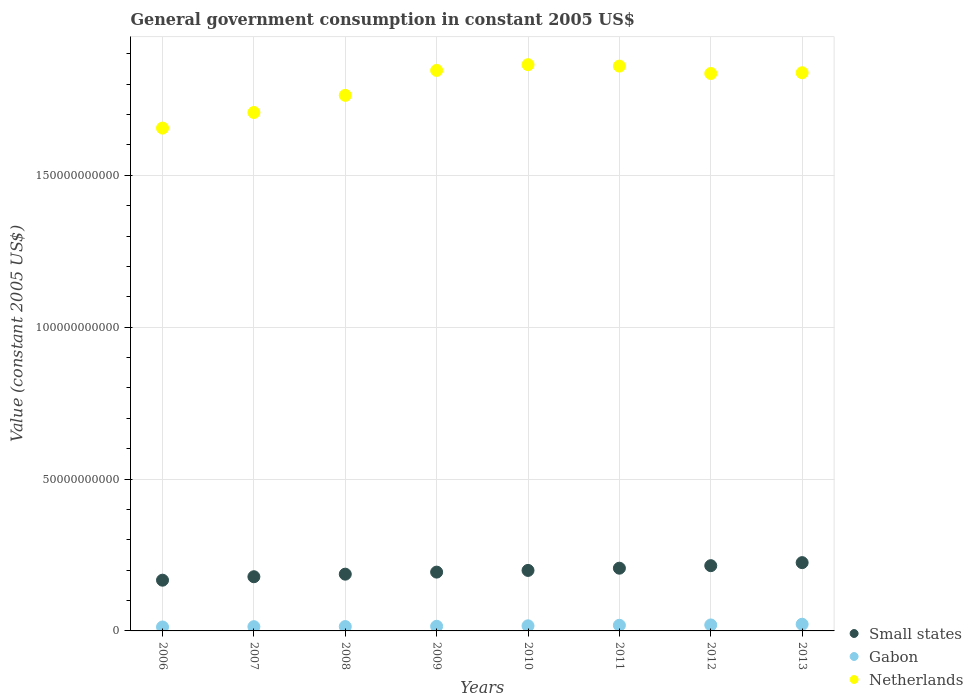How many different coloured dotlines are there?
Keep it short and to the point. 3. What is the government conusmption in Netherlands in 2011?
Offer a terse response. 1.86e+11. Across all years, what is the maximum government conusmption in Gabon?
Your response must be concise. 2.20e+09. Across all years, what is the minimum government conusmption in Small states?
Provide a succinct answer. 1.67e+1. In which year was the government conusmption in Netherlands maximum?
Your answer should be compact. 2010. What is the total government conusmption in Small states in the graph?
Make the answer very short. 1.57e+11. What is the difference between the government conusmption in Gabon in 2010 and that in 2012?
Ensure brevity in your answer.  -2.80e+08. What is the difference between the government conusmption in Small states in 2013 and the government conusmption in Gabon in 2007?
Your answer should be very brief. 2.11e+1. What is the average government conusmption in Gabon per year?
Offer a terse response. 1.67e+09. In the year 2011, what is the difference between the government conusmption in Small states and government conusmption in Gabon?
Your response must be concise. 1.88e+1. In how many years, is the government conusmption in Gabon greater than 70000000000 US$?
Provide a short and direct response. 0. What is the ratio of the government conusmption in Small states in 2007 to that in 2013?
Ensure brevity in your answer.  0.79. Is the government conusmption in Small states in 2011 less than that in 2013?
Offer a very short reply. Yes. Is the difference between the government conusmption in Small states in 2011 and 2012 greater than the difference between the government conusmption in Gabon in 2011 and 2012?
Keep it short and to the point. No. What is the difference between the highest and the second highest government conusmption in Netherlands?
Ensure brevity in your answer.  4.61e+08. What is the difference between the highest and the lowest government conusmption in Small states?
Your answer should be very brief. 5.78e+09. Is the sum of the government conusmption in Netherlands in 2006 and 2010 greater than the maximum government conusmption in Gabon across all years?
Make the answer very short. Yes. Is it the case that in every year, the sum of the government conusmption in Small states and government conusmption in Gabon  is greater than the government conusmption in Netherlands?
Your answer should be very brief. No. Does the government conusmption in Gabon monotonically increase over the years?
Your answer should be very brief. Yes. Are the values on the major ticks of Y-axis written in scientific E-notation?
Your response must be concise. No. Does the graph contain any zero values?
Keep it short and to the point. No. How many legend labels are there?
Ensure brevity in your answer.  3. How are the legend labels stacked?
Keep it short and to the point. Vertical. What is the title of the graph?
Offer a terse response. General government consumption in constant 2005 US$. Does "Iraq" appear as one of the legend labels in the graph?
Give a very brief answer. No. What is the label or title of the Y-axis?
Your answer should be compact. Value (constant 2005 US$). What is the Value (constant 2005 US$) in Small states in 2006?
Your answer should be very brief. 1.67e+1. What is the Value (constant 2005 US$) in Gabon in 2006?
Your answer should be compact. 1.29e+09. What is the Value (constant 2005 US$) of Netherlands in 2006?
Give a very brief answer. 1.66e+11. What is the Value (constant 2005 US$) of Small states in 2007?
Provide a succinct answer. 1.78e+1. What is the Value (constant 2005 US$) in Gabon in 2007?
Ensure brevity in your answer.  1.40e+09. What is the Value (constant 2005 US$) of Netherlands in 2007?
Your answer should be compact. 1.71e+11. What is the Value (constant 2005 US$) of Small states in 2008?
Provide a succinct answer. 1.87e+1. What is the Value (constant 2005 US$) of Gabon in 2008?
Make the answer very short. 1.43e+09. What is the Value (constant 2005 US$) of Netherlands in 2008?
Your response must be concise. 1.76e+11. What is the Value (constant 2005 US$) in Small states in 2009?
Offer a very short reply. 1.94e+1. What is the Value (constant 2005 US$) in Gabon in 2009?
Make the answer very short. 1.53e+09. What is the Value (constant 2005 US$) in Netherlands in 2009?
Your answer should be compact. 1.85e+11. What is the Value (constant 2005 US$) in Small states in 2010?
Offer a very short reply. 1.99e+1. What is the Value (constant 2005 US$) of Gabon in 2010?
Ensure brevity in your answer.  1.69e+09. What is the Value (constant 2005 US$) of Netherlands in 2010?
Your answer should be very brief. 1.86e+11. What is the Value (constant 2005 US$) of Small states in 2011?
Ensure brevity in your answer.  2.06e+1. What is the Value (constant 2005 US$) of Gabon in 2011?
Offer a very short reply. 1.86e+09. What is the Value (constant 2005 US$) in Netherlands in 2011?
Your response must be concise. 1.86e+11. What is the Value (constant 2005 US$) in Small states in 2012?
Your response must be concise. 2.15e+1. What is the Value (constant 2005 US$) of Gabon in 2012?
Offer a very short reply. 1.97e+09. What is the Value (constant 2005 US$) in Netherlands in 2012?
Offer a terse response. 1.83e+11. What is the Value (constant 2005 US$) of Small states in 2013?
Your answer should be compact. 2.25e+1. What is the Value (constant 2005 US$) of Gabon in 2013?
Provide a succinct answer. 2.20e+09. What is the Value (constant 2005 US$) of Netherlands in 2013?
Offer a terse response. 1.84e+11. Across all years, what is the maximum Value (constant 2005 US$) of Small states?
Your response must be concise. 2.25e+1. Across all years, what is the maximum Value (constant 2005 US$) in Gabon?
Offer a very short reply. 2.20e+09. Across all years, what is the maximum Value (constant 2005 US$) in Netherlands?
Your response must be concise. 1.86e+11. Across all years, what is the minimum Value (constant 2005 US$) in Small states?
Make the answer very short. 1.67e+1. Across all years, what is the minimum Value (constant 2005 US$) in Gabon?
Provide a short and direct response. 1.29e+09. Across all years, what is the minimum Value (constant 2005 US$) of Netherlands?
Offer a terse response. 1.66e+11. What is the total Value (constant 2005 US$) of Small states in the graph?
Keep it short and to the point. 1.57e+11. What is the total Value (constant 2005 US$) in Gabon in the graph?
Make the answer very short. 1.34e+1. What is the total Value (constant 2005 US$) of Netherlands in the graph?
Give a very brief answer. 1.44e+12. What is the difference between the Value (constant 2005 US$) in Small states in 2006 and that in 2007?
Keep it short and to the point. -1.14e+09. What is the difference between the Value (constant 2005 US$) in Gabon in 2006 and that in 2007?
Offer a very short reply. -1.03e+08. What is the difference between the Value (constant 2005 US$) of Netherlands in 2006 and that in 2007?
Offer a very short reply. -5.14e+09. What is the difference between the Value (constant 2005 US$) of Small states in 2006 and that in 2008?
Your answer should be very brief. -1.98e+09. What is the difference between the Value (constant 2005 US$) of Gabon in 2006 and that in 2008?
Give a very brief answer. -1.40e+08. What is the difference between the Value (constant 2005 US$) of Netherlands in 2006 and that in 2008?
Your answer should be compact. -1.08e+1. What is the difference between the Value (constant 2005 US$) of Small states in 2006 and that in 2009?
Make the answer very short. -2.66e+09. What is the difference between the Value (constant 2005 US$) of Gabon in 2006 and that in 2009?
Make the answer very short. -2.36e+08. What is the difference between the Value (constant 2005 US$) in Netherlands in 2006 and that in 2009?
Offer a very short reply. -1.90e+1. What is the difference between the Value (constant 2005 US$) in Small states in 2006 and that in 2010?
Offer a terse response. -3.22e+09. What is the difference between the Value (constant 2005 US$) in Gabon in 2006 and that in 2010?
Provide a succinct answer. -3.93e+08. What is the difference between the Value (constant 2005 US$) of Netherlands in 2006 and that in 2010?
Provide a succinct answer. -2.09e+1. What is the difference between the Value (constant 2005 US$) of Small states in 2006 and that in 2011?
Provide a short and direct response. -3.95e+09. What is the difference between the Value (constant 2005 US$) of Gabon in 2006 and that in 2011?
Provide a short and direct response. -5.65e+08. What is the difference between the Value (constant 2005 US$) of Netherlands in 2006 and that in 2011?
Keep it short and to the point. -2.04e+1. What is the difference between the Value (constant 2005 US$) in Small states in 2006 and that in 2012?
Ensure brevity in your answer.  -4.77e+09. What is the difference between the Value (constant 2005 US$) in Gabon in 2006 and that in 2012?
Your answer should be compact. -6.73e+08. What is the difference between the Value (constant 2005 US$) in Netherlands in 2006 and that in 2012?
Make the answer very short. -1.80e+1. What is the difference between the Value (constant 2005 US$) of Small states in 2006 and that in 2013?
Offer a terse response. -5.78e+09. What is the difference between the Value (constant 2005 US$) of Gabon in 2006 and that in 2013?
Offer a very short reply. -9.06e+08. What is the difference between the Value (constant 2005 US$) in Netherlands in 2006 and that in 2013?
Your response must be concise. -1.82e+1. What is the difference between the Value (constant 2005 US$) of Small states in 2007 and that in 2008?
Keep it short and to the point. -8.44e+08. What is the difference between the Value (constant 2005 US$) in Gabon in 2007 and that in 2008?
Make the answer very short. -3.73e+07. What is the difference between the Value (constant 2005 US$) of Netherlands in 2007 and that in 2008?
Offer a terse response. -5.64e+09. What is the difference between the Value (constant 2005 US$) in Small states in 2007 and that in 2009?
Your answer should be compact. -1.52e+09. What is the difference between the Value (constant 2005 US$) of Gabon in 2007 and that in 2009?
Ensure brevity in your answer.  -1.33e+08. What is the difference between the Value (constant 2005 US$) in Netherlands in 2007 and that in 2009?
Your answer should be compact. -1.39e+1. What is the difference between the Value (constant 2005 US$) in Small states in 2007 and that in 2010?
Your answer should be compact. -2.08e+09. What is the difference between the Value (constant 2005 US$) in Gabon in 2007 and that in 2010?
Offer a very short reply. -2.90e+08. What is the difference between the Value (constant 2005 US$) in Netherlands in 2007 and that in 2010?
Your response must be concise. -1.57e+1. What is the difference between the Value (constant 2005 US$) of Small states in 2007 and that in 2011?
Your response must be concise. -2.81e+09. What is the difference between the Value (constant 2005 US$) of Gabon in 2007 and that in 2011?
Your answer should be compact. -4.62e+08. What is the difference between the Value (constant 2005 US$) in Netherlands in 2007 and that in 2011?
Make the answer very short. -1.53e+1. What is the difference between the Value (constant 2005 US$) of Small states in 2007 and that in 2012?
Your answer should be compact. -3.64e+09. What is the difference between the Value (constant 2005 US$) of Gabon in 2007 and that in 2012?
Offer a terse response. -5.70e+08. What is the difference between the Value (constant 2005 US$) in Netherlands in 2007 and that in 2012?
Give a very brief answer. -1.28e+1. What is the difference between the Value (constant 2005 US$) of Small states in 2007 and that in 2013?
Your answer should be very brief. -4.64e+09. What is the difference between the Value (constant 2005 US$) in Gabon in 2007 and that in 2013?
Provide a short and direct response. -8.03e+08. What is the difference between the Value (constant 2005 US$) of Netherlands in 2007 and that in 2013?
Make the answer very short. -1.31e+1. What is the difference between the Value (constant 2005 US$) of Small states in 2008 and that in 2009?
Make the answer very short. -6.75e+08. What is the difference between the Value (constant 2005 US$) of Gabon in 2008 and that in 2009?
Make the answer very short. -9.54e+07. What is the difference between the Value (constant 2005 US$) in Netherlands in 2008 and that in 2009?
Give a very brief answer. -8.21e+09. What is the difference between the Value (constant 2005 US$) of Small states in 2008 and that in 2010?
Offer a terse response. -1.23e+09. What is the difference between the Value (constant 2005 US$) of Gabon in 2008 and that in 2010?
Keep it short and to the point. -2.53e+08. What is the difference between the Value (constant 2005 US$) in Netherlands in 2008 and that in 2010?
Give a very brief answer. -1.01e+1. What is the difference between the Value (constant 2005 US$) in Small states in 2008 and that in 2011?
Make the answer very short. -1.97e+09. What is the difference between the Value (constant 2005 US$) in Gabon in 2008 and that in 2011?
Ensure brevity in your answer.  -4.25e+08. What is the difference between the Value (constant 2005 US$) in Netherlands in 2008 and that in 2011?
Your answer should be very brief. -9.63e+09. What is the difference between the Value (constant 2005 US$) of Small states in 2008 and that in 2012?
Provide a short and direct response. -2.79e+09. What is the difference between the Value (constant 2005 US$) of Gabon in 2008 and that in 2012?
Provide a succinct answer. -5.33e+08. What is the difference between the Value (constant 2005 US$) in Netherlands in 2008 and that in 2012?
Offer a very short reply. -7.19e+09. What is the difference between the Value (constant 2005 US$) in Small states in 2008 and that in 2013?
Keep it short and to the point. -3.79e+09. What is the difference between the Value (constant 2005 US$) in Gabon in 2008 and that in 2013?
Ensure brevity in your answer.  -7.66e+08. What is the difference between the Value (constant 2005 US$) of Netherlands in 2008 and that in 2013?
Make the answer very short. -7.44e+09. What is the difference between the Value (constant 2005 US$) of Small states in 2009 and that in 2010?
Keep it short and to the point. -5.59e+08. What is the difference between the Value (constant 2005 US$) of Gabon in 2009 and that in 2010?
Make the answer very short. -1.57e+08. What is the difference between the Value (constant 2005 US$) in Netherlands in 2009 and that in 2010?
Give a very brief answer. -1.89e+09. What is the difference between the Value (constant 2005 US$) in Small states in 2009 and that in 2011?
Your answer should be very brief. -1.29e+09. What is the difference between the Value (constant 2005 US$) of Gabon in 2009 and that in 2011?
Your answer should be compact. -3.30e+08. What is the difference between the Value (constant 2005 US$) of Netherlands in 2009 and that in 2011?
Ensure brevity in your answer.  -1.42e+09. What is the difference between the Value (constant 2005 US$) in Small states in 2009 and that in 2012?
Your response must be concise. -2.12e+09. What is the difference between the Value (constant 2005 US$) in Gabon in 2009 and that in 2012?
Offer a very short reply. -4.38e+08. What is the difference between the Value (constant 2005 US$) in Netherlands in 2009 and that in 2012?
Your response must be concise. 1.02e+09. What is the difference between the Value (constant 2005 US$) in Small states in 2009 and that in 2013?
Your answer should be compact. -3.12e+09. What is the difference between the Value (constant 2005 US$) of Gabon in 2009 and that in 2013?
Your response must be concise. -6.71e+08. What is the difference between the Value (constant 2005 US$) in Netherlands in 2009 and that in 2013?
Provide a short and direct response. 7.69e+08. What is the difference between the Value (constant 2005 US$) of Small states in 2010 and that in 2011?
Your response must be concise. -7.31e+08. What is the difference between the Value (constant 2005 US$) of Gabon in 2010 and that in 2011?
Make the answer very short. -1.72e+08. What is the difference between the Value (constant 2005 US$) in Netherlands in 2010 and that in 2011?
Provide a succinct answer. 4.61e+08. What is the difference between the Value (constant 2005 US$) of Small states in 2010 and that in 2012?
Give a very brief answer. -1.56e+09. What is the difference between the Value (constant 2005 US$) of Gabon in 2010 and that in 2012?
Make the answer very short. -2.80e+08. What is the difference between the Value (constant 2005 US$) of Netherlands in 2010 and that in 2012?
Make the answer very short. 2.90e+09. What is the difference between the Value (constant 2005 US$) of Small states in 2010 and that in 2013?
Provide a short and direct response. -2.56e+09. What is the difference between the Value (constant 2005 US$) of Gabon in 2010 and that in 2013?
Your response must be concise. -5.13e+08. What is the difference between the Value (constant 2005 US$) in Netherlands in 2010 and that in 2013?
Provide a succinct answer. 2.65e+09. What is the difference between the Value (constant 2005 US$) of Small states in 2011 and that in 2012?
Offer a very short reply. -8.27e+08. What is the difference between the Value (constant 2005 US$) of Gabon in 2011 and that in 2012?
Offer a very short reply. -1.08e+08. What is the difference between the Value (constant 2005 US$) in Netherlands in 2011 and that in 2012?
Offer a very short reply. 2.44e+09. What is the difference between the Value (constant 2005 US$) in Small states in 2011 and that in 2013?
Your answer should be compact. -1.83e+09. What is the difference between the Value (constant 2005 US$) in Gabon in 2011 and that in 2013?
Offer a very short reply. -3.41e+08. What is the difference between the Value (constant 2005 US$) of Netherlands in 2011 and that in 2013?
Offer a terse response. 2.19e+09. What is the difference between the Value (constant 2005 US$) in Small states in 2012 and that in 2013?
Your answer should be compact. -1.00e+09. What is the difference between the Value (constant 2005 US$) of Gabon in 2012 and that in 2013?
Your answer should be very brief. -2.33e+08. What is the difference between the Value (constant 2005 US$) in Netherlands in 2012 and that in 2013?
Your answer should be very brief. -2.47e+08. What is the difference between the Value (constant 2005 US$) in Small states in 2006 and the Value (constant 2005 US$) in Gabon in 2007?
Ensure brevity in your answer.  1.53e+1. What is the difference between the Value (constant 2005 US$) in Small states in 2006 and the Value (constant 2005 US$) in Netherlands in 2007?
Provide a succinct answer. -1.54e+11. What is the difference between the Value (constant 2005 US$) of Gabon in 2006 and the Value (constant 2005 US$) of Netherlands in 2007?
Give a very brief answer. -1.69e+11. What is the difference between the Value (constant 2005 US$) in Small states in 2006 and the Value (constant 2005 US$) in Gabon in 2008?
Offer a terse response. 1.53e+1. What is the difference between the Value (constant 2005 US$) in Small states in 2006 and the Value (constant 2005 US$) in Netherlands in 2008?
Provide a short and direct response. -1.60e+11. What is the difference between the Value (constant 2005 US$) of Gabon in 2006 and the Value (constant 2005 US$) of Netherlands in 2008?
Ensure brevity in your answer.  -1.75e+11. What is the difference between the Value (constant 2005 US$) of Small states in 2006 and the Value (constant 2005 US$) of Gabon in 2009?
Make the answer very short. 1.52e+1. What is the difference between the Value (constant 2005 US$) of Small states in 2006 and the Value (constant 2005 US$) of Netherlands in 2009?
Your answer should be very brief. -1.68e+11. What is the difference between the Value (constant 2005 US$) of Gabon in 2006 and the Value (constant 2005 US$) of Netherlands in 2009?
Offer a terse response. -1.83e+11. What is the difference between the Value (constant 2005 US$) in Small states in 2006 and the Value (constant 2005 US$) in Gabon in 2010?
Ensure brevity in your answer.  1.50e+1. What is the difference between the Value (constant 2005 US$) of Small states in 2006 and the Value (constant 2005 US$) of Netherlands in 2010?
Offer a very short reply. -1.70e+11. What is the difference between the Value (constant 2005 US$) in Gabon in 2006 and the Value (constant 2005 US$) in Netherlands in 2010?
Keep it short and to the point. -1.85e+11. What is the difference between the Value (constant 2005 US$) of Small states in 2006 and the Value (constant 2005 US$) of Gabon in 2011?
Give a very brief answer. 1.48e+1. What is the difference between the Value (constant 2005 US$) of Small states in 2006 and the Value (constant 2005 US$) of Netherlands in 2011?
Your answer should be compact. -1.69e+11. What is the difference between the Value (constant 2005 US$) of Gabon in 2006 and the Value (constant 2005 US$) of Netherlands in 2011?
Keep it short and to the point. -1.85e+11. What is the difference between the Value (constant 2005 US$) of Small states in 2006 and the Value (constant 2005 US$) of Gabon in 2012?
Your answer should be compact. 1.47e+1. What is the difference between the Value (constant 2005 US$) of Small states in 2006 and the Value (constant 2005 US$) of Netherlands in 2012?
Provide a short and direct response. -1.67e+11. What is the difference between the Value (constant 2005 US$) of Gabon in 2006 and the Value (constant 2005 US$) of Netherlands in 2012?
Give a very brief answer. -1.82e+11. What is the difference between the Value (constant 2005 US$) of Small states in 2006 and the Value (constant 2005 US$) of Gabon in 2013?
Your answer should be very brief. 1.45e+1. What is the difference between the Value (constant 2005 US$) of Small states in 2006 and the Value (constant 2005 US$) of Netherlands in 2013?
Provide a succinct answer. -1.67e+11. What is the difference between the Value (constant 2005 US$) in Gabon in 2006 and the Value (constant 2005 US$) in Netherlands in 2013?
Your answer should be compact. -1.82e+11. What is the difference between the Value (constant 2005 US$) of Small states in 2007 and the Value (constant 2005 US$) of Gabon in 2008?
Your answer should be compact. 1.64e+1. What is the difference between the Value (constant 2005 US$) in Small states in 2007 and the Value (constant 2005 US$) in Netherlands in 2008?
Offer a very short reply. -1.58e+11. What is the difference between the Value (constant 2005 US$) in Gabon in 2007 and the Value (constant 2005 US$) in Netherlands in 2008?
Provide a short and direct response. -1.75e+11. What is the difference between the Value (constant 2005 US$) of Small states in 2007 and the Value (constant 2005 US$) of Gabon in 2009?
Give a very brief answer. 1.63e+1. What is the difference between the Value (constant 2005 US$) of Small states in 2007 and the Value (constant 2005 US$) of Netherlands in 2009?
Keep it short and to the point. -1.67e+11. What is the difference between the Value (constant 2005 US$) of Gabon in 2007 and the Value (constant 2005 US$) of Netherlands in 2009?
Provide a succinct answer. -1.83e+11. What is the difference between the Value (constant 2005 US$) of Small states in 2007 and the Value (constant 2005 US$) of Gabon in 2010?
Keep it short and to the point. 1.62e+1. What is the difference between the Value (constant 2005 US$) of Small states in 2007 and the Value (constant 2005 US$) of Netherlands in 2010?
Provide a short and direct response. -1.69e+11. What is the difference between the Value (constant 2005 US$) in Gabon in 2007 and the Value (constant 2005 US$) in Netherlands in 2010?
Offer a very short reply. -1.85e+11. What is the difference between the Value (constant 2005 US$) of Small states in 2007 and the Value (constant 2005 US$) of Gabon in 2011?
Give a very brief answer. 1.60e+1. What is the difference between the Value (constant 2005 US$) in Small states in 2007 and the Value (constant 2005 US$) in Netherlands in 2011?
Offer a terse response. -1.68e+11. What is the difference between the Value (constant 2005 US$) of Gabon in 2007 and the Value (constant 2005 US$) of Netherlands in 2011?
Give a very brief answer. -1.85e+11. What is the difference between the Value (constant 2005 US$) in Small states in 2007 and the Value (constant 2005 US$) in Gabon in 2012?
Your answer should be very brief. 1.59e+1. What is the difference between the Value (constant 2005 US$) of Small states in 2007 and the Value (constant 2005 US$) of Netherlands in 2012?
Your answer should be very brief. -1.66e+11. What is the difference between the Value (constant 2005 US$) of Gabon in 2007 and the Value (constant 2005 US$) of Netherlands in 2012?
Make the answer very short. -1.82e+11. What is the difference between the Value (constant 2005 US$) in Small states in 2007 and the Value (constant 2005 US$) in Gabon in 2013?
Provide a succinct answer. 1.56e+1. What is the difference between the Value (constant 2005 US$) of Small states in 2007 and the Value (constant 2005 US$) of Netherlands in 2013?
Your answer should be compact. -1.66e+11. What is the difference between the Value (constant 2005 US$) in Gabon in 2007 and the Value (constant 2005 US$) in Netherlands in 2013?
Your answer should be compact. -1.82e+11. What is the difference between the Value (constant 2005 US$) of Small states in 2008 and the Value (constant 2005 US$) of Gabon in 2009?
Provide a succinct answer. 1.72e+1. What is the difference between the Value (constant 2005 US$) in Small states in 2008 and the Value (constant 2005 US$) in Netherlands in 2009?
Your response must be concise. -1.66e+11. What is the difference between the Value (constant 2005 US$) in Gabon in 2008 and the Value (constant 2005 US$) in Netherlands in 2009?
Your answer should be very brief. -1.83e+11. What is the difference between the Value (constant 2005 US$) in Small states in 2008 and the Value (constant 2005 US$) in Gabon in 2010?
Offer a terse response. 1.70e+1. What is the difference between the Value (constant 2005 US$) of Small states in 2008 and the Value (constant 2005 US$) of Netherlands in 2010?
Offer a terse response. -1.68e+11. What is the difference between the Value (constant 2005 US$) in Gabon in 2008 and the Value (constant 2005 US$) in Netherlands in 2010?
Offer a terse response. -1.85e+11. What is the difference between the Value (constant 2005 US$) in Small states in 2008 and the Value (constant 2005 US$) in Gabon in 2011?
Offer a very short reply. 1.68e+1. What is the difference between the Value (constant 2005 US$) in Small states in 2008 and the Value (constant 2005 US$) in Netherlands in 2011?
Your response must be concise. -1.67e+11. What is the difference between the Value (constant 2005 US$) of Gabon in 2008 and the Value (constant 2005 US$) of Netherlands in 2011?
Provide a short and direct response. -1.84e+11. What is the difference between the Value (constant 2005 US$) in Small states in 2008 and the Value (constant 2005 US$) in Gabon in 2012?
Make the answer very short. 1.67e+1. What is the difference between the Value (constant 2005 US$) of Small states in 2008 and the Value (constant 2005 US$) of Netherlands in 2012?
Provide a succinct answer. -1.65e+11. What is the difference between the Value (constant 2005 US$) in Gabon in 2008 and the Value (constant 2005 US$) in Netherlands in 2012?
Give a very brief answer. -1.82e+11. What is the difference between the Value (constant 2005 US$) in Small states in 2008 and the Value (constant 2005 US$) in Gabon in 2013?
Offer a terse response. 1.65e+1. What is the difference between the Value (constant 2005 US$) of Small states in 2008 and the Value (constant 2005 US$) of Netherlands in 2013?
Provide a short and direct response. -1.65e+11. What is the difference between the Value (constant 2005 US$) of Gabon in 2008 and the Value (constant 2005 US$) of Netherlands in 2013?
Your answer should be compact. -1.82e+11. What is the difference between the Value (constant 2005 US$) of Small states in 2009 and the Value (constant 2005 US$) of Gabon in 2010?
Give a very brief answer. 1.77e+1. What is the difference between the Value (constant 2005 US$) of Small states in 2009 and the Value (constant 2005 US$) of Netherlands in 2010?
Provide a short and direct response. -1.67e+11. What is the difference between the Value (constant 2005 US$) of Gabon in 2009 and the Value (constant 2005 US$) of Netherlands in 2010?
Your answer should be very brief. -1.85e+11. What is the difference between the Value (constant 2005 US$) of Small states in 2009 and the Value (constant 2005 US$) of Gabon in 2011?
Offer a very short reply. 1.75e+1. What is the difference between the Value (constant 2005 US$) in Small states in 2009 and the Value (constant 2005 US$) in Netherlands in 2011?
Keep it short and to the point. -1.67e+11. What is the difference between the Value (constant 2005 US$) of Gabon in 2009 and the Value (constant 2005 US$) of Netherlands in 2011?
Your response must be concise. -1.84e+11. What is the difference between the Value (constant 2005 US$) in Small states in 2009 and the Value (constant 2005 US$) in Gabon in 2012?
Make the answer very short. 1.74e+1. What is the difference between the Value (constant 2005 US$) of Small states in 2009 and the Value (constant 2005 US$) of Netherlands in 2012?
Provide a short and direct response. -1.64e+11. What is the difference between the Value (constant 2005 US$) in Gabon in 2009 and the Value (constant 2005 US$) in Netherlands in 2012?
Your response must be concise. -1.82e+11. What is the difference between the Value (constant 2005 US$) of Small states in 2009 and the Value (constant 2005 US$) of Gabon in 2013?
Your response must be concise. 1.72e+1. What is the difference between the Value (constant 2005 US$) in Small states in 2009 and the Value (constant 2005 US$) in Netherlands in 2013?
Your answer should be compact. -1.64e+11. What is the difference between the Value (constant 2005 US$) in Gabon in 2009 and the Value (constant 2005 US$) in Netherlands in 2013?
Give a very brief answer. -1.82e+11. What is the difference between the Value (constant 2005 US$) of Small states in 2010 and the Value (constant 2005 US$) of Gabon in 2011?
Your answer should be very brief. 1.81e+1. What is the difference between the Value (constant 2005 US$) in Small states in 2010 and the Value (constant 2005 US$) in Netherlands in 2011?
Give a very brief answer. -1.66e+11. What is the difference between the Value (constant 2005 US$) in Gabon in 2010 and the Value (constant 2005 US$) in Netherlands in 2011?
Provide a succinct answer. -1.84e+11. What is the difference between the Value (constant 2005 US$) of Small states in 2010 and the Value (constant 2005 US$) of Gabon in 2012?
Your answer should be compact. 1.80e+1. What is the difference between the Value (constant 2005 US$) in Small states in 2010 and the Value (constant 2005 US$) in Netherlands in 2012?
Your response must be concise. -1.64e+11. What is the difference between the Value (constant 2005 US$) in Gabon in 2010 and the Value (constant 2005 US$) in Netherlands in 2012?
Provide a short and direct response. -1.82e+11. What is the difference between the Value (constant 2005 US$) in Small states in 2010 and the Value (constant 2005 US$) in Gabon in 2013?
Your response must be concise. 1.77e+1. What is the difference between the Value (constant 2005 US$) of Small states in 2010 and the Value (constant 2005 US$) of Netherlands in 2013?
Ensure brevity in your answer.  -1.64e+11. What is the difference between the Value (constant 2005 US$) of Gabon in 2010 and the Value (constant 2005 US$) of Netherlands in 2013?
Provide a short and direct response. -1.82e+11. What is the difference between the Value (constant 2005 US$) of Small states in 2011 and the Value (constant 2005 US$) of Gabon in 2012?
Give a very brief answer. 1.87e+1. What is the difference between the Value (constant 2005 US$) in Small states in 2011 and the Value (constant 2005 US$) in Netherlands in 2012?
Your response must be concise. -1.63e+11. What is the difference between the Value (constant 2005 US$) of Gabon in 2011 and the Value (constant 2005 US$) of Netherlands in 2012?
Give a very brief answer. -1.82e+11. What is the difference between the Value (constant 2005 US$) of Small states in 2011 and the Value (constant 2005 US$) of Gabon in 2013?
Offer a terse response. 1.85e+1. What is the difference between the Value (constant 2005 US$) in Small states in 2011 and the Value (constant 2005 US$) in Netherlands in 2013?
Offer a very short reply. -1.63e+11. What is the difference between the Value (constant 2005 US$) of Gabon in 2011 and the Value (constant 2005 US$) of Netherlands in 2013?
Offer a very short reply. -1.82e+11. What is the difference between the Value (constant 2005 US$) of Small states in 2012 and the Value (constant 2005 US$) of Gabon in 2013?
Offer a very short reply. 1.93e+1. What is the difference between the Value (constant 2005 US$) in Small states in 2012 and the Value (constant 2005 US$) in Netherlands in 2013?
Your answer should be compact. -1.62e+11. What is the difference between the Value (constant 2005 US$) in Gabon in 2012 and the Value (constant 2005 US$) in Netherlands in 2013?
Offer a very short reply. -1.82e+11. What is the average Value (constant 2005 US$) in Small states per year?
Provide a short and direct response. 1.96e+1. What is the average Value (constant 2005 US$) of Gabon per year?
Ensure brevity in your answer.  1.67e+09. What is the average Value (constant 2005 US$) in Netherlands per year?
Ensure brevity in your answer.  1.80e+11. In the year 2006, what is the difference between the Value (constant 2005 US$) in Small states and Value (constant 2005 US$) in Gabon?
Offer a terse response. 1.54e+1. In the year 2006, what is the difference between the Value (constant 2005 US$) of Small states and Value (constant 2005 US$) of Netherlands?
Ensure brevity in your answer.  -1.49e+11. In the year 2006, what is the difference between the Value (constant 2005 US$) in Gabon and Value (constant 2005 US$) in Netherlands?
Ensure brevity in your answer.  -1.64e+11. In the year 2007, what is the difference between the Value (constant 2005 US$) of Small states and Value (constant 2005 US$) of Gabon?
Offer a very short reply. 1.64e+1. In the year 2007, what is the difference between the Value (constant 2005 US$) of Small states and Value (constant 2005 US$) of Netherlands?
Keep it short and to the point. -1.53e+11. In the year 2007, what is the difference between the Value (constant 2005 US$) of Gabon and Value (constant 2005 US$) of Netherlands?
Offer a very short reply. -1.69e+11. In the year 2008, what is the difference between the Value (constant 2005 US$) of Small states and Value (constant 2005 US$) of Gabon?
Provide a succinct answer. 1.73e+1. In the year 2008, what is the difference between the Value (constant 2005 US$) of Small states and Value (constant 2005 US$) of Netherlands?
Give a very brief answer. -1.58e+11. In the year 2008, what is the difference between the Value (constant 2005 US$) of Gabon and Value (constant 2005 US$) of Netherlands?
Keep it short and to the point. -1.75e+11. In the year 2009, what is the difference between the Value (constant 2005 US$) of Small states and Value (constant 2005 US$) of Gabon?
Provide a short and direct response. 1.78e+1. In the year 2009, what is the difference between the Value (constant 2005 US$) of Small states and Value (constant 2005 US$) of Netherlands?
Keep it short and to the point. -1.65e+11. In the year 2009, what is the difference between the Value (constant 2005 US$) in Gabon and Value (constant 2005 US$) in Netherlands?
Make the answer very short. -1.83e+11. In the year 2010, what is the difference between the Value (constant 2005 US$) of Small states and Value (constant 2005 US$) of Gabon?
Your response must be concise. 1.82e+1. In the year 2010, what is the difference between the Value (constant 2005 US$) of Small states and Value (constant 2005 US$) of Netherlands?
Your answer should be very brief. -1.66e+11. In the year 2010, what is the difference between the Value (constant 2005 US$) in Gabon and Value (constant 2005 US$) in Netherlands?
Your answer should be very brief. -1.85e+11. In the year 2011, what is the difference between the Value (constant 2005 US$) in Small states and Value (constant 2005 US$) in Gabon?
Provide a short and direct response. 1.88e+1. In the year 2011, what is the difference between the Value (constant 2005 US$) of Small states and Value (constant 2005 US$) of Netherlands?
Give a very brief answer. -1.65e+11. In the year 2011, what is the difference between the Value (constant 2005 US$) of Gabon and Value (constant 2005 US$) of Netherlands?
Keep it short and to the point. -1.84e+11. In the year 2012, what is the difference between the Value (constant 2005 US$) in Small states and Value (constant 2005 US$) in Gabon?
Offer a terse response. 1.95e+1. In the year 2012, what is the difference between the Value (constant 2005 US$) of Small states and Value (constant 2005 US$) of Netherlands?
Keep it short and to the point. -1.62e+11. In the year 2012, what is the difference between the Value (constant 2005 US$) in Gabon and Value (constant 2005 US$) in Netherlands?
Offer a terse response. -1.82e+11. In the year 2013, what is the difference between the Value (constant 2005 US$) in Small states and Value (constant 2005 US$) in Gabon?
Offer a terse response. 2.03e+1. In the year 2013, what is the difference between the Value (constant 2005 US$) in Small states and Value (constant 2005 US$) in Netherlands?
Keep it short and to the point. -1.61e+11. In the year 2013, what is the difference between the Value (constant 2005 US$) of Gabon and Value (constant 2005 US$) of Netherlands?
Ensure brevity in your answer.  -1.82e+11. What is the ratio of the Value (constant 2005 US$) of Small states in 2006 to that in 2007?
Keep it short and to the point. 0.94. What is the ratio of the Value (constant 2005 US$) of Gabon in 2006 to that in 2007?
Your answer should be compact. 0.93. What is the ratio of the Value (constant 2005 US$) of Netherlands in 2006 to that in 2007?
Provide a short and direct response. 0.97. What is the ratio of the Value (constant 2005 US$) of Small states in 2006 to that in 2008?
Keep it short and to the point. 0.89. What is the ratio of the Value (constant 2005 US$) in Gabon in 2006 to that in 2008?
Your answer should be very brief. 0.9. What is the ratio of the Value (constant 2005 US$) in Netherlands in 2006 to that in 2008?
Ensure brevity in your answer.  0.94. What is the ratio of the Value (constant 2005 US$) in Small states in 2006 to that in 2009?
Your answer should be compact. 0.86. What is the ratio of the Value (constant 2005 US$) in Gabon in 2006 to that in 2009?
Your answer should be compact. 0.85. What is the ratio of the Value (constant 2005 US$) of Netherlands in 2006 to that in 2009?
Offer a terse response. 0.9. What is the ratio of the Value (constant 2005 US$) of Small states in 2006 to that in 2010?
Provide a short and direct response. 0.84. What is the ratio of the Value (constant 2005 US$) of Gabon in 2006 to that in 2010?
Keep it short and to the point. 0.77. What is the ratio of the Value (constant 2005 US$) in Netherlands in 2006 to that in 2010?
Provide a succinct answer. 0.89. What is the ratio of the Value (constant 2005 US$) of Small states in 2006 to that in 2011?
Keep it short and to the point. 0.81. What is the ratio of the Value (constant 2005 US$) of Gabon in 2006 to that in 2011?
Provide a short and direct response. 0.7. What is the ratio of the Value (constant 2005 US$) in Netherlands in 2006 to that in 2011?
Make the answer very short. 0.89. What is the ratio of the Value (constant 2005 US$) of Small states in 2006 to that in 2012?
Your answer should be compact. 0.78. What is the ratio of the Value (constant 2005 US$) in Gabon in 2006 to that in 2012?
Offer a terse response. 0.66. What is the ratio of the Value (constant 2005 US$) in Netherlands in 2006 to that in 2012?
Your response must be concise. 0.9. What is the ratio of the Value (constant 2005 US$) in Small states in 2006 to that in 2013?
Ensure brevity in your answer.  0.74. What is the ratio of the Value (constant 2005 US$) in Gabon in 2006 to that in 2013?
Your response must be concise. 0.59. What is the ratio of the Value (constant 2005 US$) in Netherlands in 2006 to that in 2013?
Make the answer very short. 0.9. What is the ratio of the Value (constant 2005 US$) of Small states in 2007 to that in 2008?
Ensure brevity in your answer.  0.95. What is the ratio of the Value (constant 2005 US$) of Netherlands in 2007 to that in 2008?
Keep it short and to the point. 0.97. What is the ratio of the Value (constant 2005 US$) of Small states in 2007 to that in 2009?
Provide a succinct answer. 0.92. What is the ratio of the Value (constant 2005 US$) of Gabon in 2007 to that in 2009?
Your response must be concise. 0.91. What is the ratio of the Value (constant 2005 US$) of Netherlands in 2007 to that in 2009?
Ensure brevity in your answer.  0.92. What is the ratio of the Value (constant 2005 US$) of Small states in 2007 to that in 2010?
Your answer should be compact. 0.9. What is the ratio of the Value (constant 2005 US$) of Gabon in 2007 to that in 2010?
Your answer should be very brief. 0.83. What is the ratio of the Value (constant 2005 US$) in Netherlands in 2007 to that in 2010?
Provide a succinct answer. 0.92. What is the ratio of the Value (constant 2005 US$) in Small states in 2007 to that in 2011?
Your answer should be compact. 0.86. What is the ratio of the Value (constant 2005 US$) in Gabon in 2007 to that in 2011?
Make the answer very short. 0.75. What is the ratio of the Value (constant 2005 US$) of Netherlands in 2007 to that in 2011?
Your response must be concise. 0.92. What is the ratio of the Value (constant 2005 US$) in Small states in 2007 to that in 2012?
Your response must be concise. 0.83. What is the ratio of the Value (constant 2005 US$) in Gabon in 2007 to that in 2012?
Provide a succinct answer. 0.71. What is the ratio of the Value (constant 2005 US$) of Netherlands in 2007 to that in 2012?
Provide a short and direct response. 0.93. What is the ratio of the Value (constant 2005 US$) in Small states in 2007 to that in 2013?
Ensure brevity in your answer.  0.79. What is the ratio of the Value (constant 2005 US$) of Gabon in 2007 to that in 2013?
Your answer should be very brief. 0.63. What is the ratio of the Value (constant 2005 US$) in Netherlands in 2007 to that in 2013?
Your response must be concise. 0.93. What is the ratio of the Value (constant 2005 US$) of Small states in 2008 to that in 2009?
Provide a short and direct response. 0.97. What is the ratio of the Value (constant 2005 US$) in Gabon in 2008 to that in 2009?
Offer a very short reply. 0.94. What is the ratio of the Value (constant 2005 US$) in Netherlands in 2008 to that in 2009?
Your answer should be compact. 0.96. What is the ratio of the Value (constant 2005 US$) of Small states in 2008 to that in 2010?
Provide a succinct answer. 0.94. What is the ratio of the Value (constant 2005 US$) in Netherlands in 2008 to that in 2010?
Give a very brief answer. 0.95. What is the ratio of the Value (constant 2005 US$) of Small states in 2008 to that in 2011?
Keep it short and to the point. 0.9. What is the ratio of the Value (constant 2005 US$) of Gabon in 2008 to that in 2011?
Provide a succinct answer. 0.77. What is the ratio of the Value (constant 2005 US$) of Netherlands in 2008 to that in 2011?
Provide a succinct answer. 0.95. What is the ratio of the Value (constant 2005 US$) of Small states in 2008 to that in 2012?
Your answer should be very brief. 0.87. What is the ratio of the Value (constant 2005 US$) in Gabon in 2008 to that in 2012?
Provide a succinct answer. 0.73. What is the ratio of the Value (constant 2005 US$) of Netherlands in 2008 to that in 2012?
Offer a very short reply. 0.96. What is the ratio of the Value (constant 2005 US$) in Small states in 2008 to that in 2013?
Give a very brief answer. 0.83. What is the ratio of the Value (constant 2005 US$) in Gabon in 2008 to that in 2013?
Your response must be concise. 0.65. What is the ratio of the Value (constant 2005 US$) of Netherlands in 2008 to that in 2013?
Make the answer very short. 0.96. What is the ratio of the Value (constant 2005 US$) in Small states in 2009 to that in 2010?
Provide a short and direct response. 0.97. What is the ratio of the Value (constant 2005 US$) of Gabon in 2009 to that in 2010?
Your response must be concise. 0.91. What is the ratio of the Value (constant 2005 US$) in Small states in 2009 to that in 2011?
Offer a very short reply. 0.94. What is the ratio of the Value (constant 2005 US$) in Gabon in 2009 to that in 2011?
Offer a very short reply. 0.82. What is the ratio of the Value (constant 2005 US$) in Small states in 2009 to that in 2012?
Keep it short and to the point. 0.9. What is the ratio of the Value (constant 2005 US$) of Gabon in 2009 to that in 2012?
Give a very brief answer. 0.78. What is the ratio of the Value (constant 2005 US$) of Netherlands in 2009 to that in 2012?
Give a very brief answer. 1.01. What is the ratio of the Value (constant 2005 US$) in Small states in 2009 to that in 2013?
Give a very brief answer. 0.86. What is the ratio of the Value (constant 2005 US$) of Gabon in 2009 to that in 2013?
Ensure brevity in your answer.  0.69. What is the ratio of the Value (constant 2005 US$) in Netherlands in 2009 to that in 2013?
Your answer should be very brief. 1. What is the ratio of the Value (constant 2005 US$) in Small states in 2010 to that in 2011?
Offer a very short reply. 0.96. What is the ratio of the Value (constant 2005 US$) in Gabon in 2010 to that in 2011?
Your answer should be compact. 0.91. What is the ratio of the Value (constant 2005 US$) of Netherlands in 2010 to that in 2011?
Ensure brevity in your answer.  1. What is the ratio of the Value (constant 2005 US$) of Small states in 2010 to that in 2012?
Your response must be concise. 0.93. What is the ratio of the Value (constant 2005 US$) of Gabon in 2010 to that in 2012?
Your response must be concise. 0.86. What is the ratio of the Value (constant 2005 US$) in Netherlands in 2010 to that in 2012?
Ensure brevity in your answer.  1.02. What is the ratio of the Value (constant 2005 US$) in Small states in 2010 to that in 2013?
Make the answer very short. 0.89. What is the ratio of the Value (constant 2005 US$) in Gabon in 2010 to that in 2013?
Keep it short and to the point. 0.77. What is the ratio of the Value (constant 2005 US$) of Netherlands in 2010 to that in 2013?
Ensure brevity in your answer.  1.01. What is the ratio of the Value (constant 2005 US$) of Small states in 2011 to that in 2012?
Offer a terse response. 0.96. What is the ratio of the Value (constant 2005 US$) in Gabon in 2011 to that in 2012?
Offer a terse response. 0.94. What is the ratio of the Value (constant 2005 US$) of Netherlands in 2011 to that in 2012?
Ensure brevity in your answer.  1.01. What is the ratio of the Value (constant 2005 US$) of Small states in 2011 to that in 2013?
Ensure brevity in your answer.  0.92. What is the ratio of the Value (constant 2005 US$) in Gabon in 2011 to that in 2013?
Give a very brief answer. 0.84. What is the ratio of the Value (constant 2005 US$) in Netherlands in 2011 to that in 2013?
Provide a succinct answer. 1.01. What is the ratio of the Value (constant 2005 US$) of Small states in 2012 to that in 2013?
Keep it short and to the point. 0.96. What is the ratio of the Value (constant 2005 US$) in Gabon in 2012 to that in 2013?
Ensure brevity in your answer.  0.89. What is the ratio of the Value (constant 2005 US$) of Netherlands in 2012 to that in 2013?
Give a very brief answer. 1. What is the difference between the highest and the second highest Value (constant 2005 US$) of Small states?
Your answer should be very brief. 1.00e+09. What is the difference between the highest and the second highest Value (constant 2005 US$) of Gabon?
Your response must be concise. 2.33e+08. What is the difference between the highest and the second highest Value (constant 2005 US$) in Netherlands?
Provide a succinct answer. 4.61e+08. What is the difference between the highest and the lowest Value (constant 2005 US$) in Small states?
Provide a succinct answer. 5.78e+09. What is the difference between the highest and the lowest Value (constant 2005 US$) in Gabon?
Give a very brief answer. 9.06e+08. What is the difference between the highest and the lowest Value (constant 2005 US$) in Netherlands?
Your answer should be very brief. 2.09e+1. 